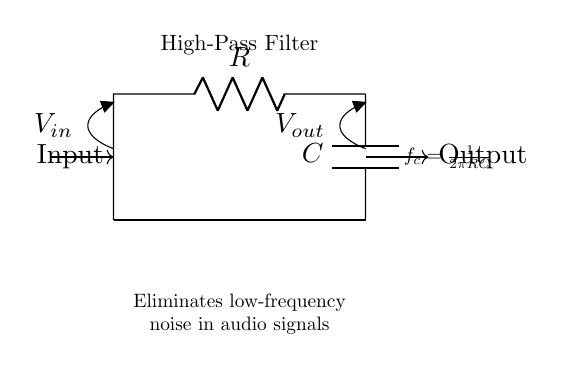What components make up this high-pass filter? The high-pass filter consists of a resistor (R) and a capacitor (C) connected in series. These components are indicated in the circuit diagram.
Answer: Resistor and Capacitor What is the role of the capacitor in this circuit? The capacitor in a high-pass filter allows high-frequency signals to pass through while blocking low-frequency signals. This property is derived from its behavior in alternating current circuits.
Answer: Block low frequencies What does the equation provided in the diagram represent? The equation \( f_c = \frac{1}{2\pi RC} \) calculates the cutoff frequency of the high-pass filter, where \( f_c \) is the frequency at which the output signal is reduced by 3 dB (half power).
Answer: Cutoff frequency calculation How is the output voltage related to the input voltage? The output voltage (Vout) will be dependent on the input voltage (Vin) and the frequency of the signal. Above the cutoff frequency, Vout approaches Vin; below the cutoff, Vout decreases significantly.
Answer: Frequency dependent What is the purpose of the high-pass filter in audio applications? The purpose is to eliminate low-frequency noise, such as hum or rumble, from audio signals, allowing cleaner sound reproduction of higher frequencies.
Answer: Eliminate low-frequency noise What happens to signals at the cutoff frequency? At the cutoff frequency, the signal experiences a reduction to about 70.7 percent of its maximum amplitude, which corresponds to a 3-decibel (3 dB) drop. This is a critical behavior characteristic of filters.
Answer: Signal reduction 